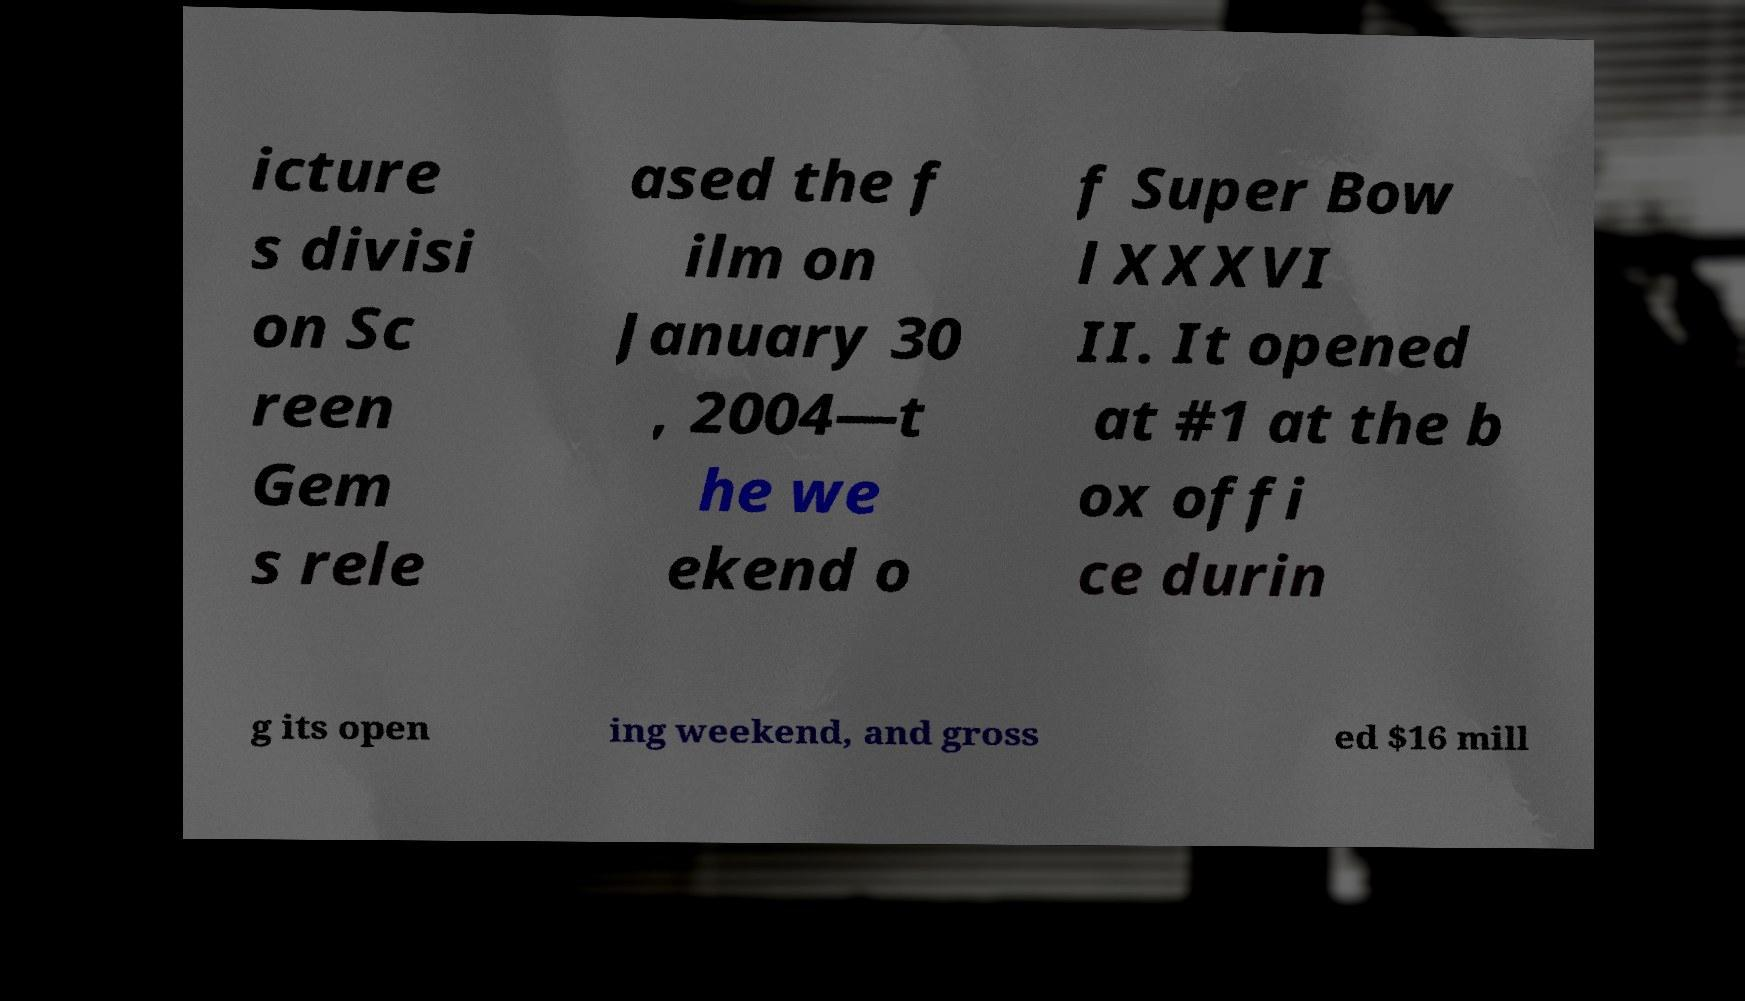For documentation purposes, I need the text within this image transcribed. Could you provide that? icture s divisi on Sc reen Gem s rele ased the f ilm on January 30 , 2004—t he we ekend o f Super Bow l XXXVI II. It opened at #1 at the b ox offi ce durin g its open ing weekend, and gross ed $16 mill 